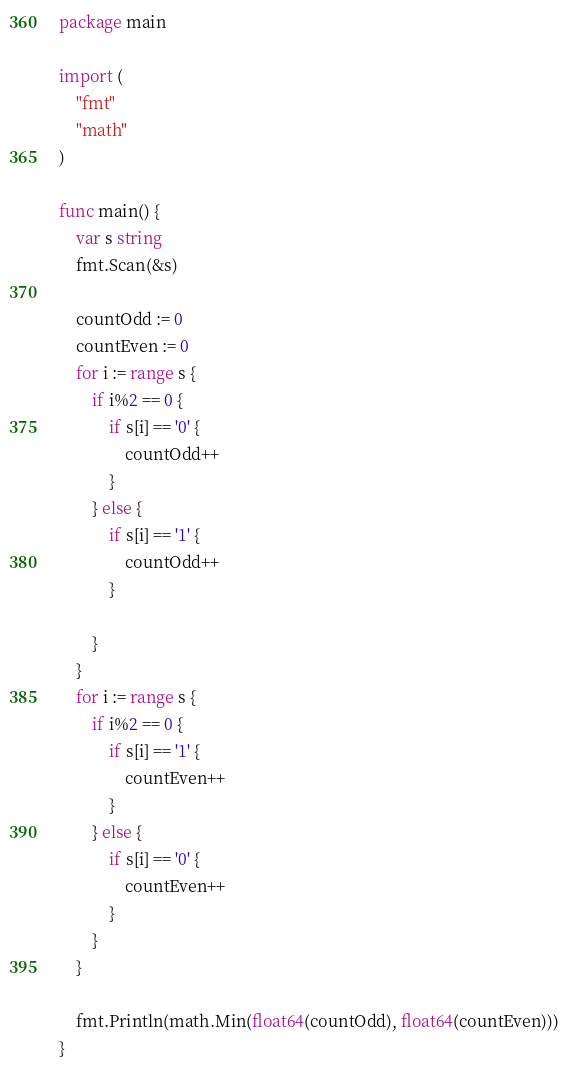Convert code to text. <code><loc_0><loc_0><loc_500><loc_500><_Go_>package main

import (
	"fmt"
	"math"
)

func main() {
	var s string
	fmt.Scan(&s)

	countOdd := 0
	countEven := 0
	for i := range s {
		if i%2 == 0 {
			if s[i] == '0' {
				countOdd++
			}
		} else {
			if s[i] == '1' {
				countOdd++
			}

		}
	}
	for i := range s {
		if i%2 == 0 {
			if s[i] == '1' {
				countEven++
			}
		} else {
			if s[i] == '0' {
				countEven++
			}
		}
	}

	fmt.Println(math.Min(float64(countOdd), float64(countEven)))
}
</code> 